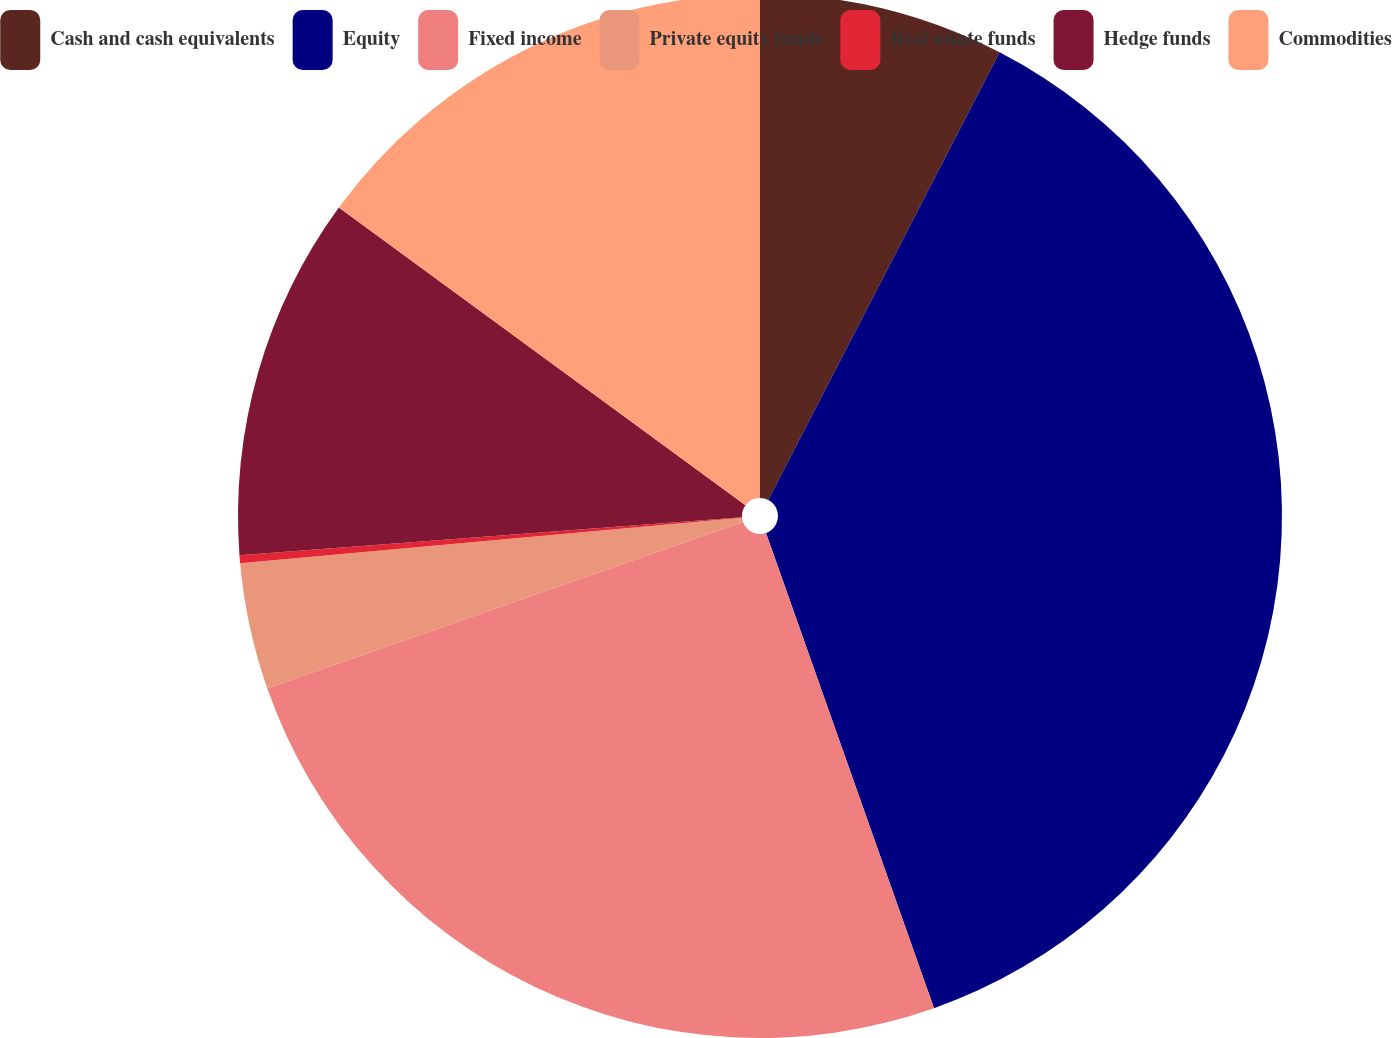<chart> <loc_0><loc_0><loc_500><loc_500><pie_chart><fcel>Cash and cash equivalents<fcel>Equity<fcel>Fixed income<fcel>Private equity funds<fcel>Real estate funds<fcel>Hedge funds<fcel>Commodities<nl><fcel>7.59%<fcel>37.0%<fcel>25.06%<fcel>3.91%<fcel>0.24%<fcel>11.26%<fcel>14.94%<nl></chart> 